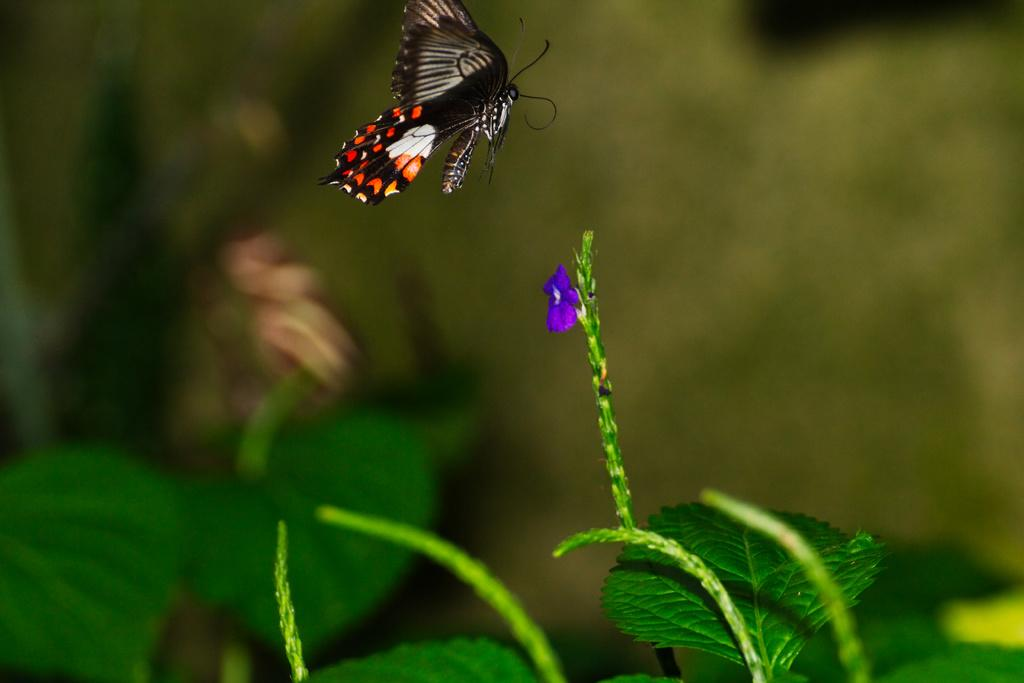What is the main subject in the center of the image? There is a butterfly in the center of the image. What can be seen at the bottom of the image? There are leaves at the bottom of the image. How would you describe the background of the image? The background of the image is blurry. What type of income can be seen on the shelf in the image? There is no shelf or income present in the image; it features a butterfly and leaves. 